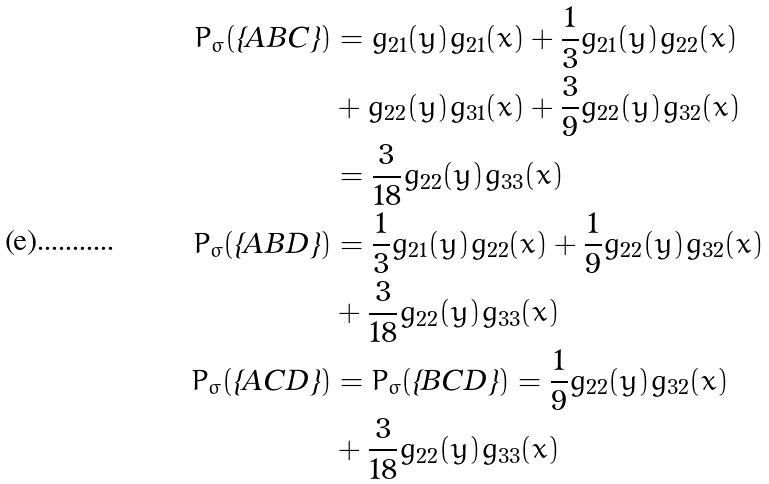Convert formula to latex. <formula><loc_0><loc_0><loc_500><loc_500>P _ { \sigma } ( \text {\{ABC\}} ) & = g _ { 2 1 } ( y ) g _ { 2 1 } ( x ) + \frac { 1 } { 3 } g _ { 2 1 } ( y ) g _ { 2 2 } ( x ) \\ & + g _ { 2 2 } ( y ) g _ { 3 1 } ( x ) + \frac { 3 } { 9 } g _ { 2 2 } ( y ) g _ { 3 2 } ( x ) \\ & = \frac { 3 } { 1 8 } g _ { 2 2 } ( y ) g _ { 3 3 } ( x ) \\ P _ { \sigma } ( \text {\{ABD\}} ) & = \frac { 1 } { 3 } g _ { 2 1 } ( y ) g _ { 2 2 } ( x ) + \frac { 1 } { 9 } g _ { 2 2 } ( y ) g _ { 3 2 } ( x ) \\ & + \frac { 3 } { 1 8 } g _ { 2 2 } ( y ) g _ { 3 3 } ( x ) \\ P _ { \sigma } ( \text {\{ACD\}} ) & = P _ { \sigma } ( \text {\{BCD\}} ) = \frac { 1 } { 9 } g _ { 2 2 } ( y ) g _ { 3 2 } ( x ) \\ & + \frac { 3 } { 1 8 } g _ { 2 2 } ( y ) g _ { 3 3 } ( x )</formula> 